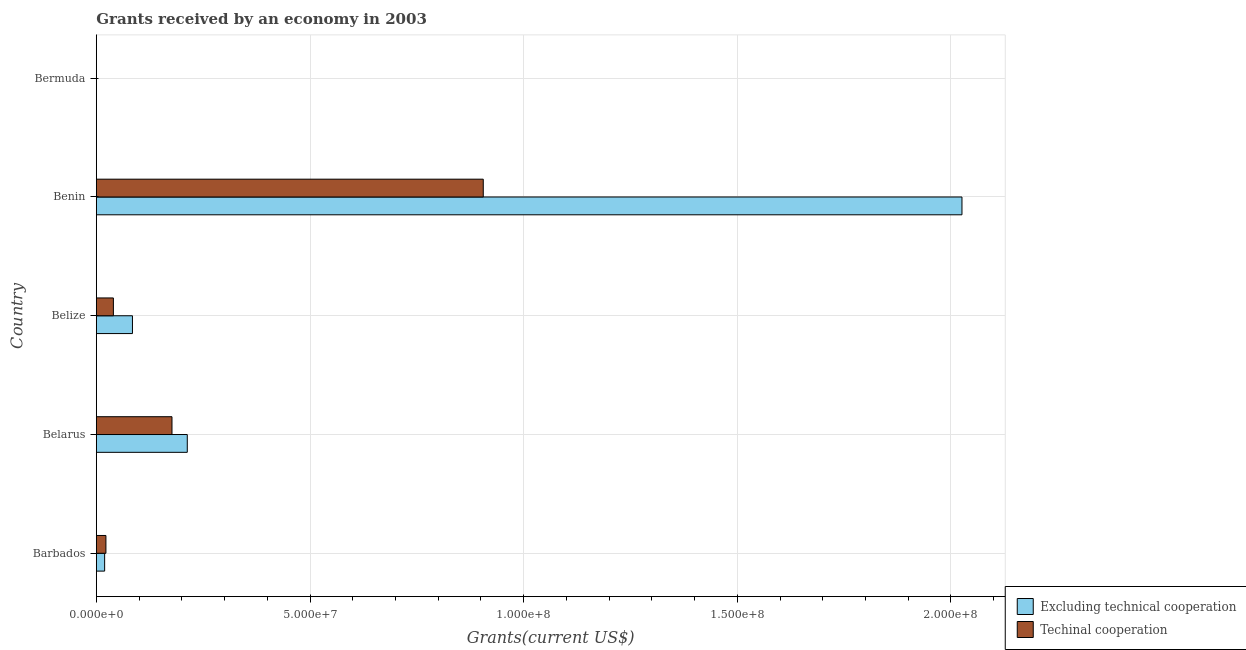Are the number of bars per tick equal to the number of legend labels?
Your answer should be very brief. Yes. Are the number of bars on each tick of the Y-axis equal?
Ensure brevity in your answer.  Yes. How many bars are there on the 5th tick from the top?
Your response must be concise. 2. What is the label of the 2nd group of bars from the top?
Offer a terse response. Benin. In how many cases, is the number of bars for a given country not equal to the number of legend labels?
Make the answer very short. 0. What is the amount of grants received(including technical cooperation) in Belarus?
Make the answer very short. 1.77e+07. Across all countries, what is the maximum amount of grants received(excluding technical cooperation)?
Your answer should be compact. 2.03e+08. Across all countries, what is the minimum amount of grants received(including technical cooperation)?
Provide a succinct answer. 2.00e+04. In which country was the amount of grants received(excluding technical cooperation) maximum?
Your answer should be compact. Benin. In which country was the amount of grants received(excluding technical cooperation) minimum?
Ensure brevity in your answer.  Bermuda. What is the total amount of grants received(excluding technical cooperation) in the graph?
Offer a terse response. 2.34e+08. What is the difference between the amount of grants received(including technical cooperation) in Belize and that in Bermuda?
Offer a very short reply. 3.97e+06. What is the difference between the amount of grants received(excluding technical cooperation) in Benin and the amount of grants received(including technical cooperation) in Barbados?
Give a very brief answer. 2.00e+08. What is the average amount of grants received(excluding technical cooperation) per country?
Make the answer very short. 4.69e+07. What is the difference between the amount of grants received(including technical cooperation) and amount of grants received(excluding technical cooperation) in Bermuda?
Provide a succinct answer. 10000. What is the ratio of the amount of grants received(including technical cooperation) in Barbados to that in Belarus?
Your response must be concise. 0.13. Is the amount of grants received(including technical cooperation) in Belarus less than that in Belize?
Offer a very short reply. No. What is the difference between the highest and the second highest amount of grants received(excluding technical cooperation)?
Your answer should be compact. 1.81e+08. What is the difference between the highest and the lowest amount of grants received(including technical cooperation)?
Give a very brief answer. 9.05e+07. Is the sum of the amount of grants received(excluding technical cooperation) in Belarus and Belize greater than the maximum amount of grants received(including technical cooperation) across all countries?
Your answer should be very brief. No. What does the 2nd bar from the top in Bermuda represents?
Offer a terse response. Excluding technical cooperation. What does the 1st bar from the bottom in Barbados represents?
Ensure brevity in your answer.  Excluding technical cooperation. Are all the bars in the graph horizontal?
Your response must be concise. Yes. How many countries are there in the graph?
Ensure brevity in your answer.  5. Does the graph contain any zero values?
Offer a terse response. No. Where does the legend appear in the graph?
Provide a succinct answer. Bottom right. How many legend labels are there?
Make the answer very short. 2. How are the legend labels stacked?
Your response must be concise. Vertical. What is the title of the graph?
Offer a terse response. Grants received by an economy in 2003. Does "Males" appear as one of the legend labels in the graph?
Give a very brief answer. No. What is the label or title of the X-axis?
Your response must be concise. Grants(current US$). What is the Grants(current US$) of Excluding technical cooperation in Barbados?
Your response must be concise. 1.94e+06. What is the Grants(current US$) in Techinal cooperation in Barbados?
Offer a terse response. 2.24e+06. What is the Grants(current US$) in Excluding technical cooperation in Belarus?
Ensure brevity in your answer.  2.13e+07. What is the Grants(current US$) of Techinal cooperation in Belarus?
Provide a succinct answer. 1.77e+07. What is the Grants(current US$) of Excluding technical cooperation in Belize?
Keep it short and to the point. 8.45e+06. What is the Grants(current US$) in Techinal cooperation in Belize?
Your answer should be compact. 3.99e+06. What is the Grants(current US$) in Excluding technical cooperation in Benin?
Your answer should be compact. 2.03e+08. What is the Grants(current US$) of Techinal cooperation in Benin?
Give a very brief answer. 9.06e+07. What is the Grants(current US$) in Techinal cooperation in Bermuda?
Provide a short and direct response. 2.00e+04. Across all countries, what is the maximum Grants(current US$) of Excluding technical cooperation?
Ensure brevity in your answer.  2.03e+08. Across all countries, what is the maximum Grants(current US$) in Techinal cooperation?
Offer a very short reply. 9.06e+07. Across all countries, what is the minimum Grants(current US$) of Excluding technical cooperation?
Your answer should be compact. 10000. Across all countries, what is the minimum Grants(current US$) of Techinal cooperation?
Give a very brief answer. 2.00e+04. What is the total Grants(current US$) in Excluding technical cooperation in the graph?
Provide a succinct answer. 2.34e+08. What is the total Grants(current US$) of Techinal cooperation in the graph?
Provide a succinct answer. 1.14e+08. What is the difference between the Grants(current US$) of Excluding technical cooperation in Barbados and that in Belarus?
Your answer should be compact. -1.93e+07. What is the difference between the Grants(current US$) in Techinal cooperation in Barbados and that in Belarus?
Ensure brevity in your answer.  -1.55e+07. What is the difference between the Grants(current US$) of Excluding technical cooperation in Barbados and that in Belize?
Provide a short and direct response. -6.51e+06. What is the difference between the Grants(current US$) in Techinal cooperation in Barbados and that in Belize?
Your answer should be compact. -1.75e+06. What is the difference between the Grants(current US$) of Excluding technical cooperation in Barbados and that in Benin?
Provide a short and direct response. -2.01e+08. What is the difference between the Grants(current US$) in Techinal cooperation in Barbados and that in Benin?
Offer a terse response. -8.83e+07. What is the difference between the Grants(current US$) of Excluding technical cooperation in Barbados and that in Bermuda?
Your answer should be compact. 1.93e+06. What is the difference between the Grants(current US$) in Techinal cooperation in Barbados and that in Bermuda?
Offer a very short reply. 2.22e+06. What is the difference between the Grants(current US$) of Excluding technical cooperation in Belarus and that in Belize?
Ensure brevity in your answer.  1.28e+07. What is the difference between the Grants(current US$) of Techinal cooperation in Belarus and that in Belize?
Offer a terse response. 1.37e+07. What is the difference between the Grants(current US$) of Excluding technical cooperation in Belarus and that in Benin?
Make the answer very short. -1.81e+08. What is the difference between the Grants(current US$) of Techinal cooperation in Belarus and that in Benin?
Ensure brevity in your answer.  -7.28e+07. What is the difference between the Grants(current US$) in Excluding technical cooperation in Belarus and that in Bermuda?
Your answer should be very brief. 2.13e+07. What is the difference between the Grants(current US$) of Techinal cooperation in Belarus and that in Bermuda?
Provide a short and direct response. 1.77e+07. What is the difference between the Grants(current US$) in Excluding technical cooperation in Belize and that in Benin?
Offer a terse response. -1.94e+08. What is the difference between the Grants(current US$) in Techinal cooperation in Belize and that in Benin?
Your answer should be very brief. -8.66e+07. What is the difference between the Grants(current US$) in Excluding technical cooperation in Belize and that in Bermuda?
Keep it short and to the point. 8.44e+06. What is the difference between the Grants(current US$) of Techinal cooperation in Belize and that in Bermuda?
Keep it short and to the point. 3.97e+06. What is the difference between the Grants(current US$) of Excluding technical cooperation in Benin and that in Bermuda?
Ensure brevity in your answer.  2.03e+08. What is the difference between the Grants(current US$) of Techinal cooperation in Benin and that in Bermuda?
Keep it short and to the point. 9.05e+07. What is the difference between the Grants(current US$) of Excluding technical cooperation in Barbados and the Grants(current US$) of Techinal cooperation in Belarus?
Your response must be concise. -1.58e+07. What is the difference between the Grants(current US$) in Excluding technical cooperation in Barbados and the Grants(current US$) in Techinal cooperation in Belize?
Offer a terse response. -2.05e+06. What is the difference between the Grants(current US$) in Excluding technical cooperation in Barbados and the Grants(current US$) in Techinal cooperation in Benin?
Your response must be concise. -8.86e+07. What is the difference between the Grants(current US$) in Excluding technical cooperation in Barbados and the Grants(current US$) in Techinal cooperation in Bermuda?
Your response must be concise. 1.92e+06. What is the difference between the Grants(current US$) of Excluding technical cooperation in Belarus and the Grants(current US$) of Techinal cooperation in Belize?
Offer a very short reply. 1.73e+07. What is the difference between the Grants(current US$) of Excluding technical cooperation in Belarus and the Grants(current US$) of Techinal cooperation in Benin?
Give a very brief answer. -6.93e+07. What is the difference between the Grants(current US$) of Excluding technical cooperation in Belarus and the Grants(current US$) of Techinal cooperation in Bermuda?
Ensure brevity in your answer.  2.13e+07. What is the difference between the Grants(current US$) in Excluding technical cooperation in Belize and the Grants(current US$) in Techinal cooperation in Benin?
Your answer should be compact. -8.21e+07. What is the difference between the Grants(current US$) of Excluding technical cooperation in Belize and the Grants(current US$) of Techinal cooperation in Bermuda?
Make the answer very short. 8.43e+06. What is the difference between the Grants(current US$) of Excluding technical cooperation in Benin and the Grants(current US$) of Techinal cooperation in Bermuda?
Give a very brief answer. 2.03e+08. What is the average Grants(current US$) in Excluding technical cooperation per country?
Offer a terse response. 4.69e+07. What is the average Grants(current US$) of Techinal cooperation per country?
Make the answer very short. 2.29e+07. What is the difference between the Grants(current US$) in Excluding technical cooperation and Grants(current US$) in Techinal cooperation in Barbados?
Ensure brevity in your answer.  -3.00e+05. What is the difference between the Grants(current US$) of Excluding technical cooperation and Grants(current US$) of Techinal cooperation in Belarus?
Provide a succinct answer. 3.58e+06. What is the difference between the Grants(current US$) of Excluding technical cooperation and Grants(current US$) of Techinal cooperation in Belize?
Make the answer very short. 4.46e+06. What is the difference between the Grants(current US$) in Excluding technical cooperation and Grants(current US$) in Techinal cooperation in Benin?
Provide a short and direct response. 1.12e+08. What is the difference between the Grants(current US$) in Excluding technical cooperation and Grants(current US$) in Techinal cooperation in Bermuda?
Give a very brief answer. -10000. What is the ratio of the Grants(current US$) of Excluding technical cooperation in Barbados to that in Belarus?
Provide a short and direct response. 0.09. What is the ratio of the Grants(current US$) in Techinal cooperation in Barbados to that in Belarus?
Offer a very short reply. 0.13. What is the ratio of the Grants(current US$) of Excluding technical cooperation in Barbados to that in Belize?
Your answer should be compact. 0.23. What is the ratio of the Grants(current US$) of Techinal cooperation in Barbados to that in Belize?
Your answer should be compact. 0.56. What is the ratio of the Grants(current US$) of Excluding technical cooperation in Barbados to that in Benin?
Keep it short and to the point. 0.01. What is the ratio of the Grants(current US$) of Techinal cooperation in Barbados to that in Benin?
Make the answer very short. 0.02. What is the ratio of the Grants(current US$) in Excluding technical cooperation in Barbados to that in Bermuda?
Provide a succinct answer. 194. What is the ratio of the Grants(current US$) of Techinal cooperation in Barbados to that in Bermuda?
Your answer should be compact. 112. What is the ratio of the Grants(current US$) in Excluding technical cooperation in Belarus to that in Belize?
Your response must be concise. 2.52. What is the ratio of the Grants(current US$) of Techinal cooperation in Belarus to that in Belize?
Make the answer very short. 4.44. What is the ratio of the Grants(current US$) of Excluding technical cooperation in Belarus to that in Benin?
Keep it short and to the point. 0.1. What is the ratio of the Grants(current US$) of Techinal cooperation in Belarus to that in Benin?
Your answer should be very brief. 0.2. What is the ratio of the Grants(current US$) in Excluding technical cooperation in Belarus to that in Bermuda?
Offer a very short reply. 2128. What is the ratio of the Grants(current US$) in Techinal cooperation in Belarus to that in Bermuda?
Make the answer very short. 885. What is the ratio of the Grants(current US$) of Excluding technical cooperation in Belize to that in Benin?
Ensure brevity in your answer.  0.04. What is the ratio of the Grants(current US$) in Techinal cooperation in Belize to that in Benin?
Offer a terse response. 0.04. What is the ratio of the Grants(current US$) in Excluding technical cooperation in Belize to that in Bermuda?
Keep it short and to the point. 845. What is the ratio of the Grants(current US$) in Techinal cooperation in Belize to that in Bermuda?
Your answer should be very brief. 199.5. What is the ratio of the Grants(current US$) in Excluding technical cooperation in Benin to that in Bermuda?
Make the answer very short. 2.03e+04. What is the ratio of the Grants(current US$) in Techinal cooperation in Benin to that in Bermuda?
Provide a short and direct response. 4527.5. What is the difference between the highest and the second highest Grants(current US$) of Excluding technical cooperation?
Ensure brevity in your answer.  1.81e+08. What is the difference between the highest and the second highest Grants(current US$) in Techinal cooperation?
Ensure brevity in your answer.  7.28e+07. What is the difference between the highest and the lowest Grants(current US$) in Excluding technical cooperation?
Provide a short and direct response. 2.03e+08. What is the difference between the highest and the lowest Grants(current US$) in Techinal cooperation?
Provide a short and direct response. 9.05e+07. 